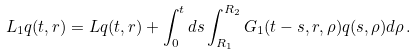<formula> <loc_0><loc_0><loc_500><loc_500>L _ { 1 } q ( t , r ) = L q ( t , r ) + \int _ { 0 } ^ { t } d s \int _ { R _ { 1 } } ^ { R _ { 2 } } G _ { 1 } ( t - s , r , \rho ) q ( s , \rho ) d \rho \, .</formula> 